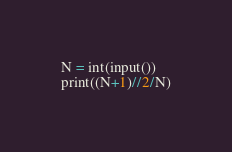<code> <loc_0><loc_0><loc_500><loc_500><_Python_>N = int(input())
print((N+1)//2/N)</code> 